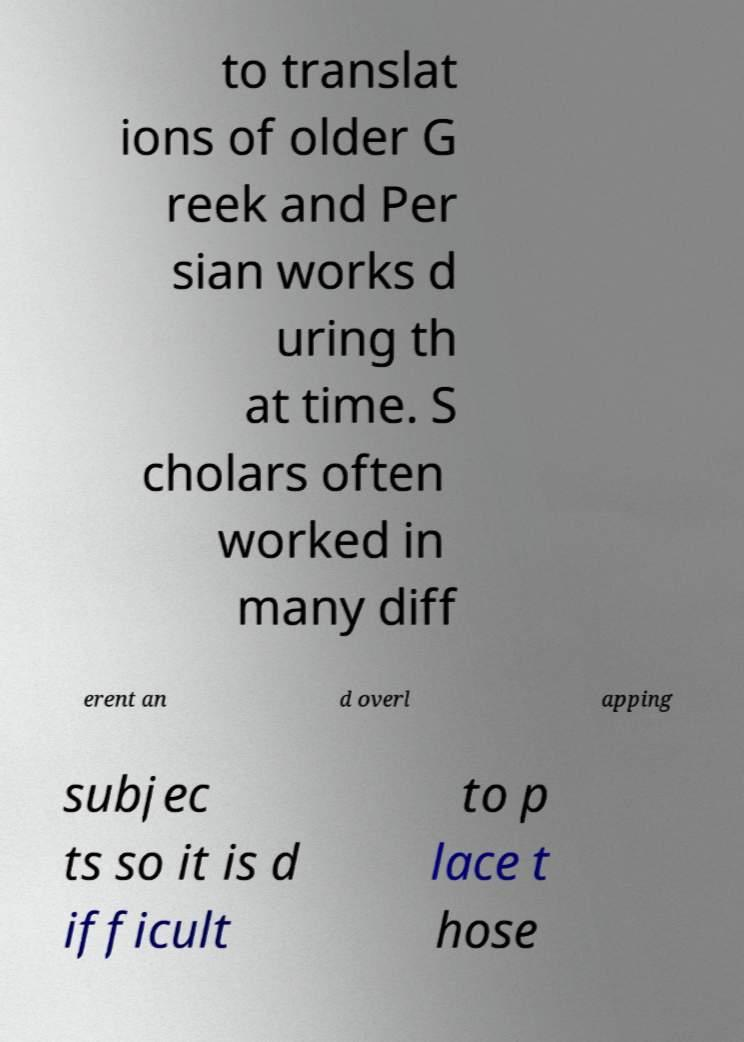Could you extract and type out the text from this image? to translat ions of older G reek and Per sian works d uring th at time. S cholars often worked in many diff erent an d overl apping subjec ts so it is d ifficult to p lace t hose 